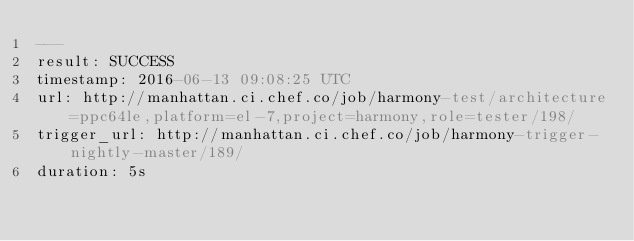<code> <loc_0><loc_0><loc_500><loc_500><_YAML_>---
result: SUCCESS
timestamp: 2016-06-13 09:08:25 UTC
url: http://manhattan.ci.chef.co/job/harmony-test/architecture=ppc64le,platform=el-7,project=harmony,role=tester/198/
trigger_url: http://manhattan.ci.chef.co/job/harmony-trigger-nightly-master/189/
duration: 5s
</code> 